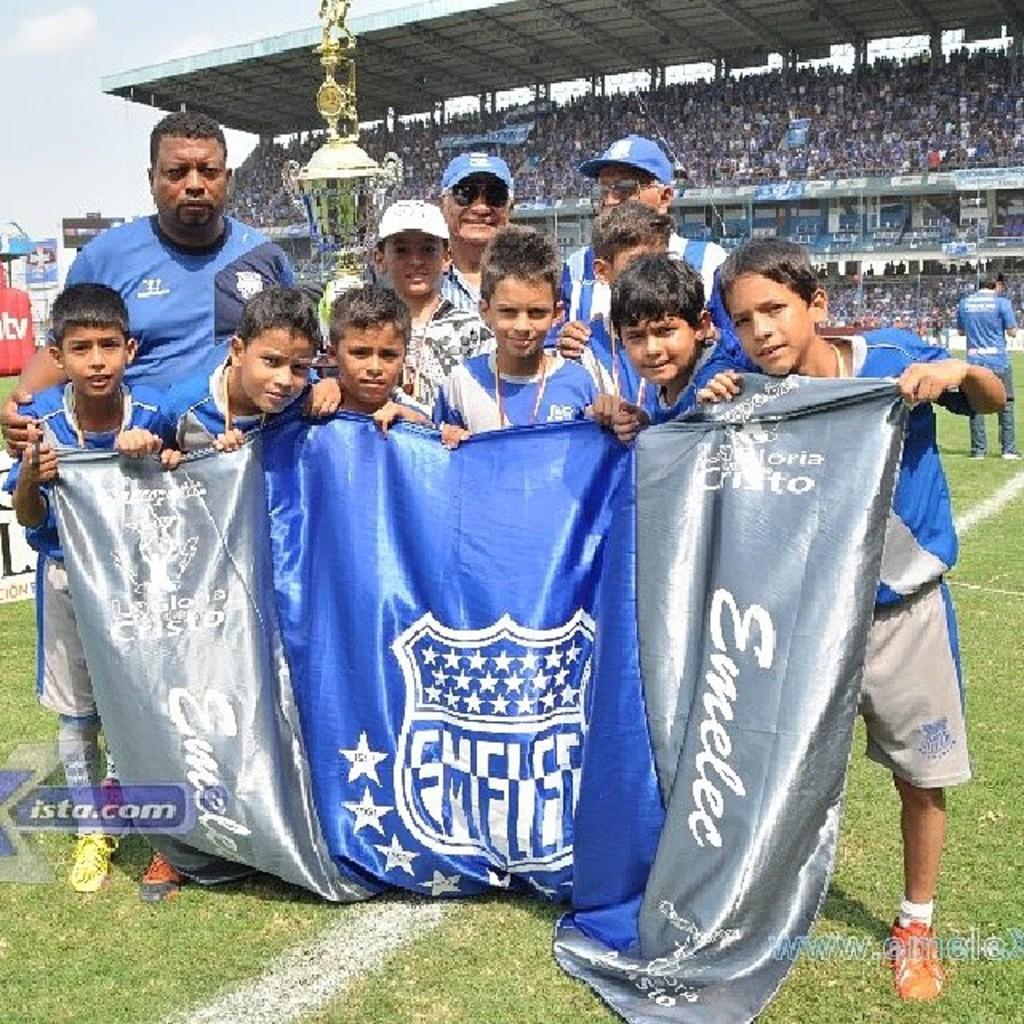What does the flag say?
Provide a short and direct response. Emelee. 